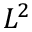<formula> <loc_0><loc_0><loc_500><loc_500>L ^ { 2 }</formula> 